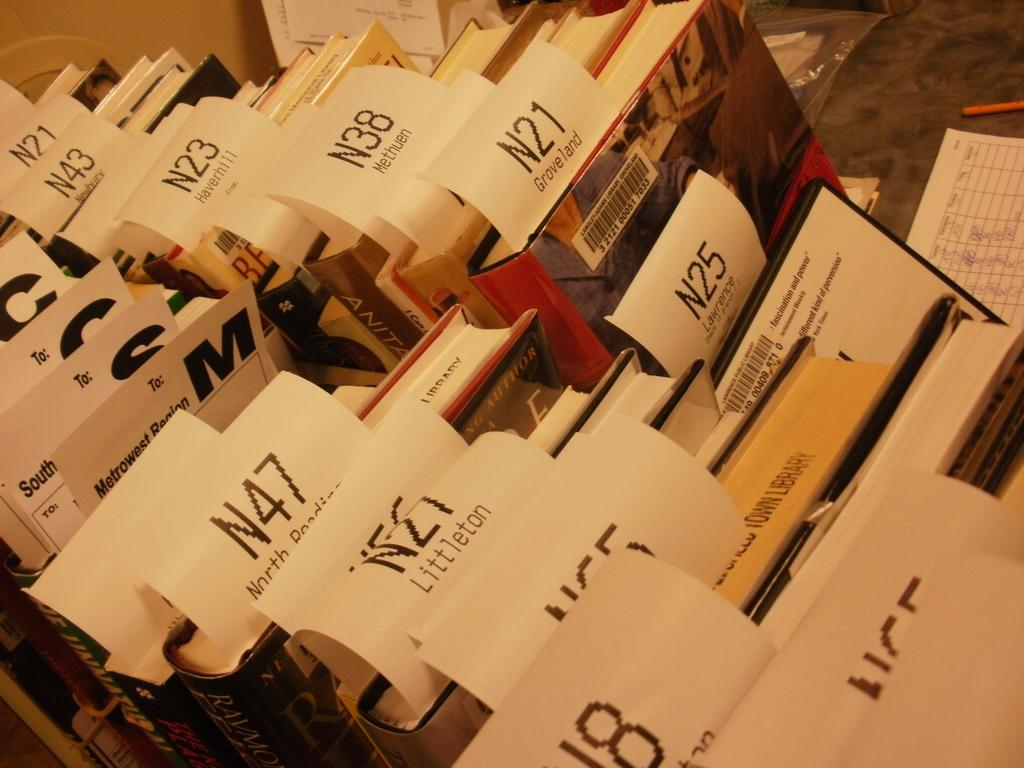<image>
Summarize the visual content of the image. Lots of books sitting on a table with receipts with numbers sticking out of them. 